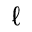Convert formula to latex. <formula><loc_0><loc_0><loc_500><loc_500>\ell</formula> 